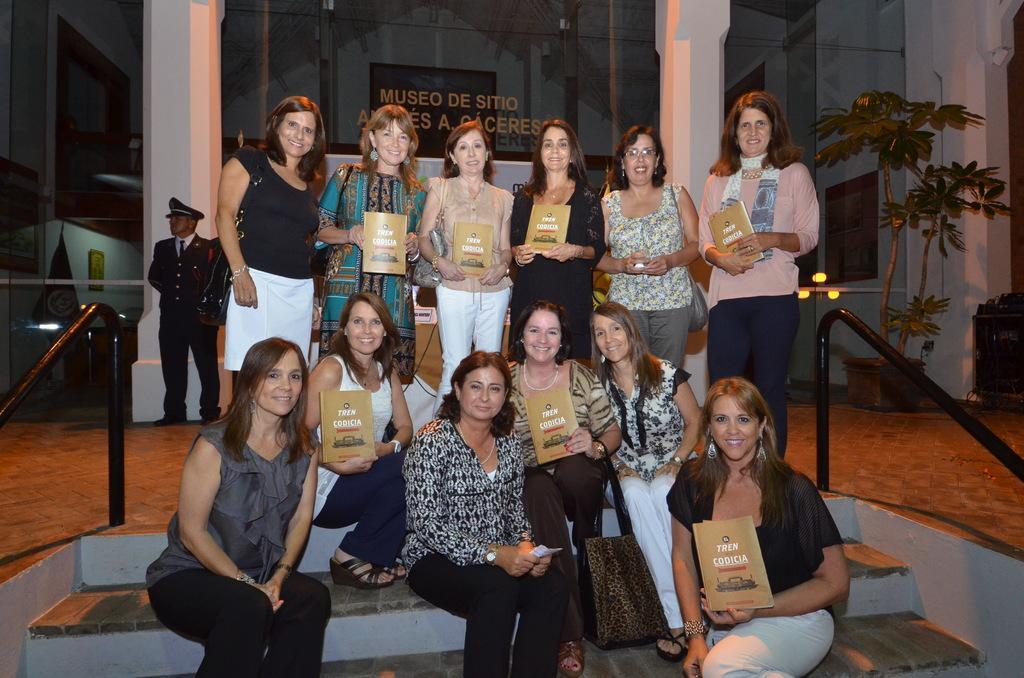How would you summarize this image in a sentence or two? In the foreground of this image, there are few men sitting on the stairs and few are standing behind them holding books. In the background, there is a man standing, glass, pillars and the wall. On either side, there is railing. 